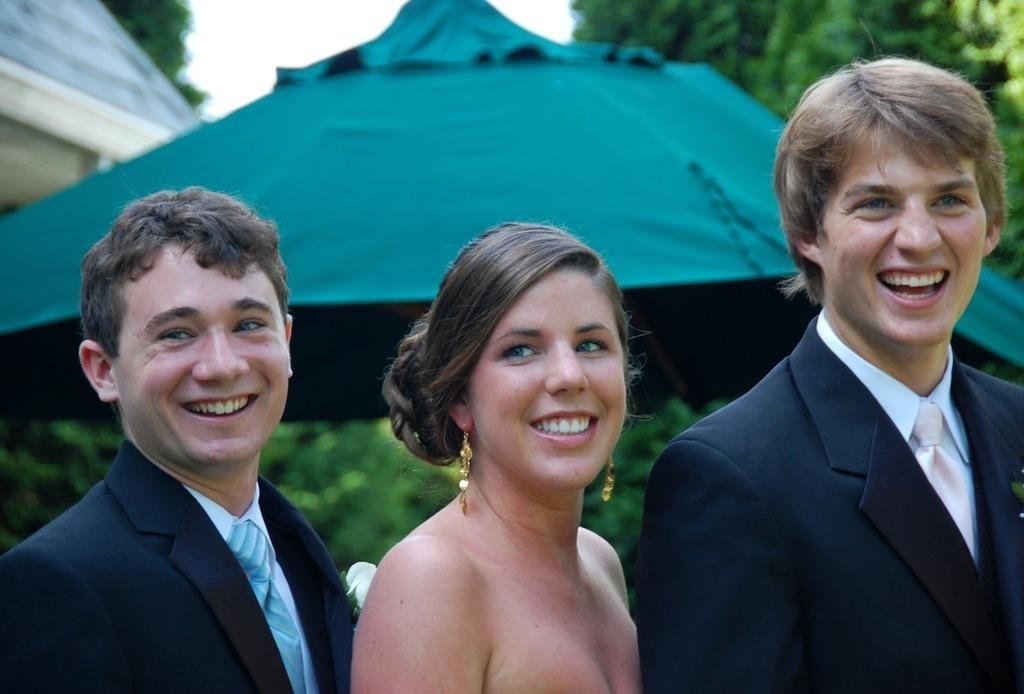How many people are in the image? There are three people in the image: one lady and two men. What are the people in the image doing? The lady and men are standing. What can be seen in the background of the image? There are trees, a tent, and a house in the background of the image. What is visible at the top of the image? The sky is visible at the top of the image. How many feet are visible in the image? There is no specific mention of feet in the image, so it is not possible to determine how many are visible. 